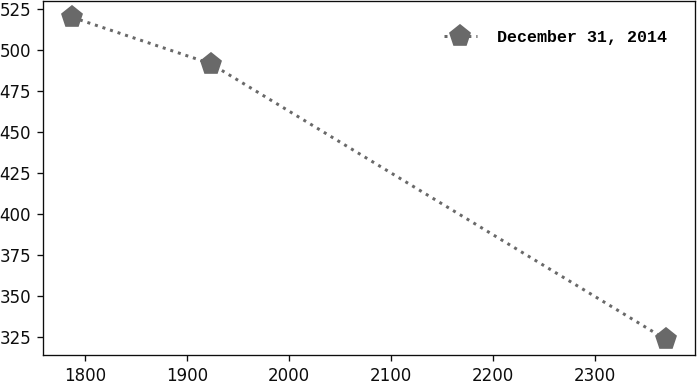Convert chart to OTSL. <chart><loc_0><loc_0><loc_500><loc_500><line_chart><ecel><fcel>December 31, 2014<nl><fcel>1787.1<fcel>519.94<nl><fcel>1922.89<fcel>491.64<nl><fcel>2369.3<fcel>323.32<nl></chart> 